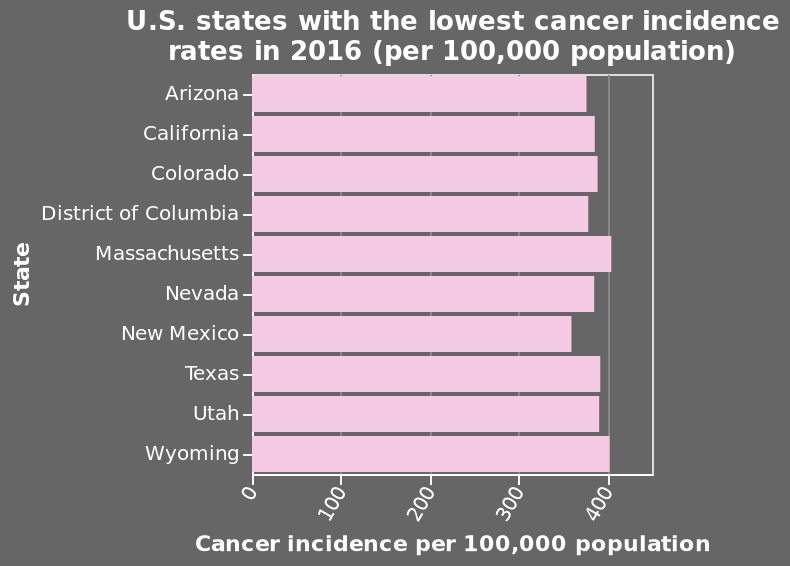<image>
What does the x-axis of the bar diagram represent? The x-axis represents the cancer incidence per 100,000 population. Which states had the highest Cancer incidence in 2016? Massachusetts and Wyoming. What was the Cancer incidence in Massachusetts and Wyoming in 2016? Around 400 per 100,000 population. 